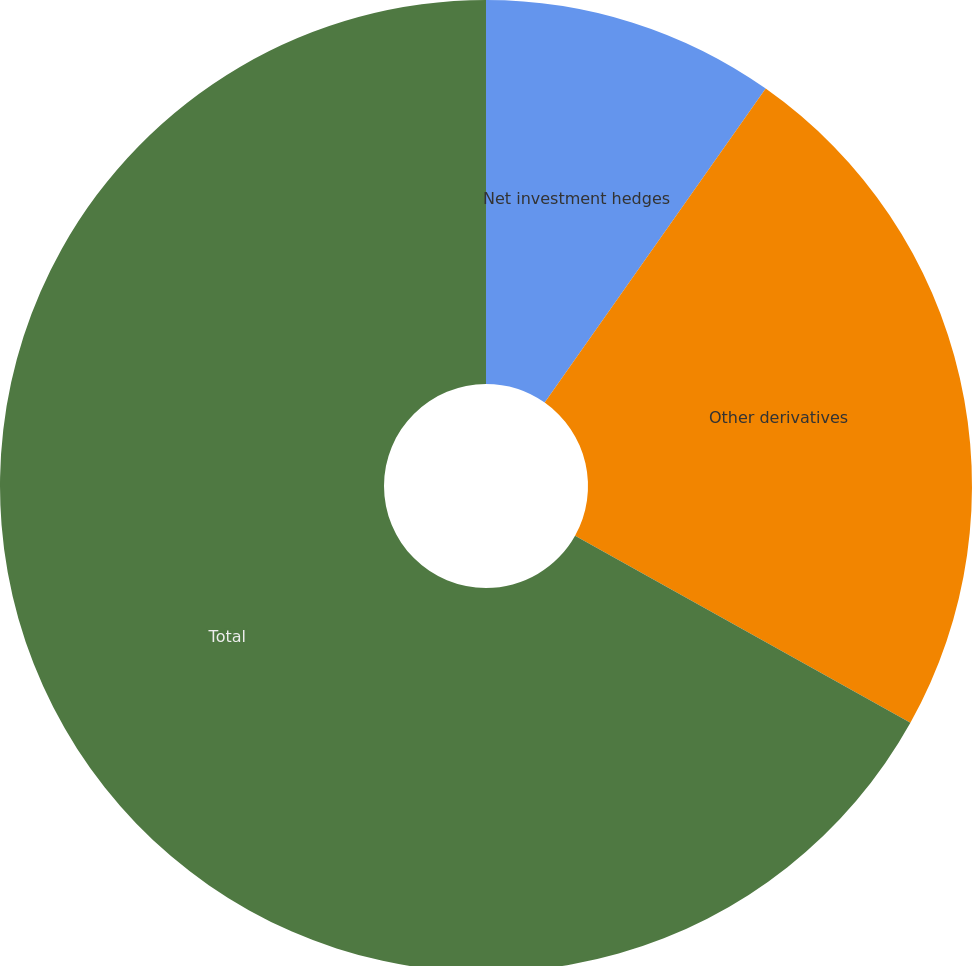Convert chart to OTSL. <chart><loc_0><loc_0><loc_500><loc_500><pie_chart><fcel>Net investment hedges<fcel>Other derivatives<fcel>Total<nl><fcel>9.76%<fcel>23.34%<fcel>66.9%<nl></chart> 